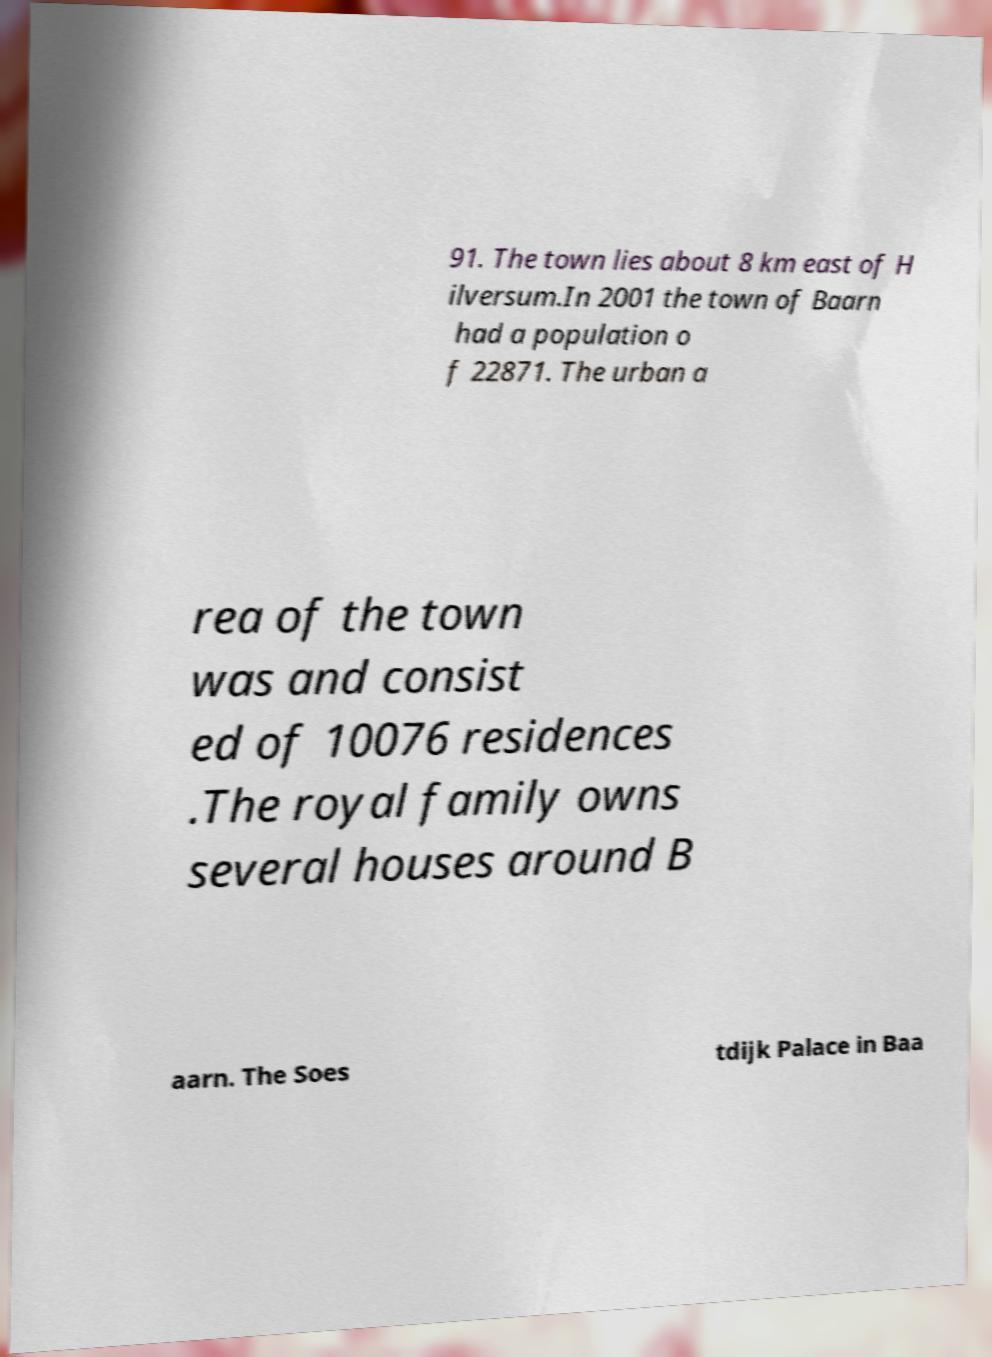I need the written content from this picture converted into text. Can you do that? 91. The town lies about 8 km east of H ilversum.In 2001 the town of Baarn had a population o f 22871. The urban a rea of the town was and consist ed of 10076 residences .The royal family owns several houses around B aarn. The Soes tdijk Palace in Baa 